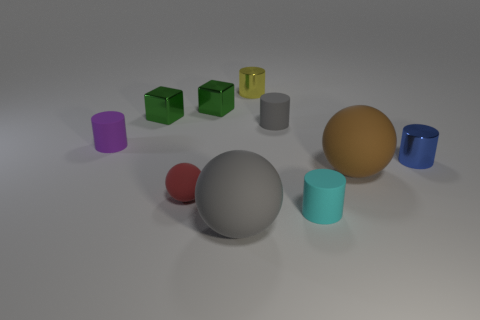How many objects are either gray things that are in front of the tiny cyan rubber thing or green things?
Offer a terse response. 3. There is a small cyan thing that is the same material as the small purple cylinder; what shape is it?
Keep it short and to the point. Cylinder. The large gray object is what shape?
Your answer should be very brief. Sphere. There is a tiny rubber cylinder that is right of the tiny red rubber object and behind the tiny rubber ball; what color is it?
Your answer should be compact. Gray. The gray rubber thing that is the same size as the cyan cylinder is what shape?
Offer a terse response. Cylinder. Is there another red rubber thing of the same shape as the red object?
Provide a short and direct response. No. Is the material of the tiny red object the same as the cylinder in front of the red thing?
Provide a short and direct response. Yes. What is the color of the tiny shiny cylinder that is behind the metallic cylinder that is in front of the gray rubber thing behind the tiny blue object?
Keep it short and to the point. Yellow. There is a ball that is the same size as the blue metal cylinder; what is it made of?
Your answer should be very brief. Rubber. What number of cylinders have the same material as the gray sphere?
Your answer should be compact. 3. 